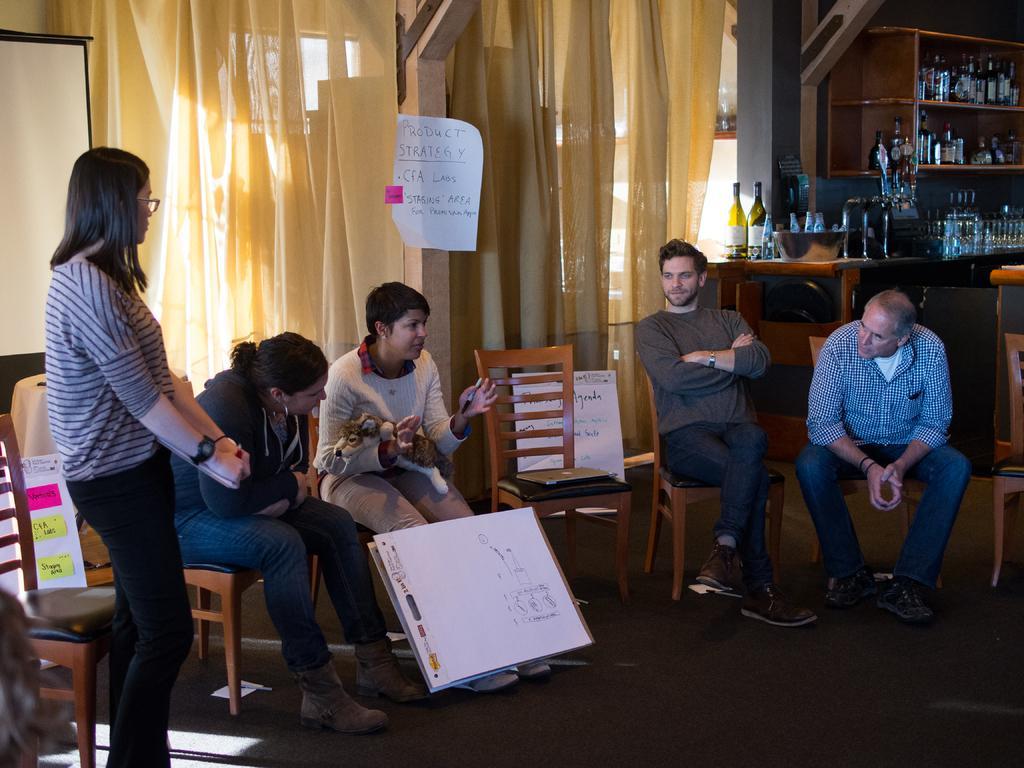How would you summarize this image in a sentence or two? In the foreground of this picture, there are person sitting and one is standing. They all are listening to the woman speaking. There are papers, curtains, a screen, bottles, pillars in the background. 